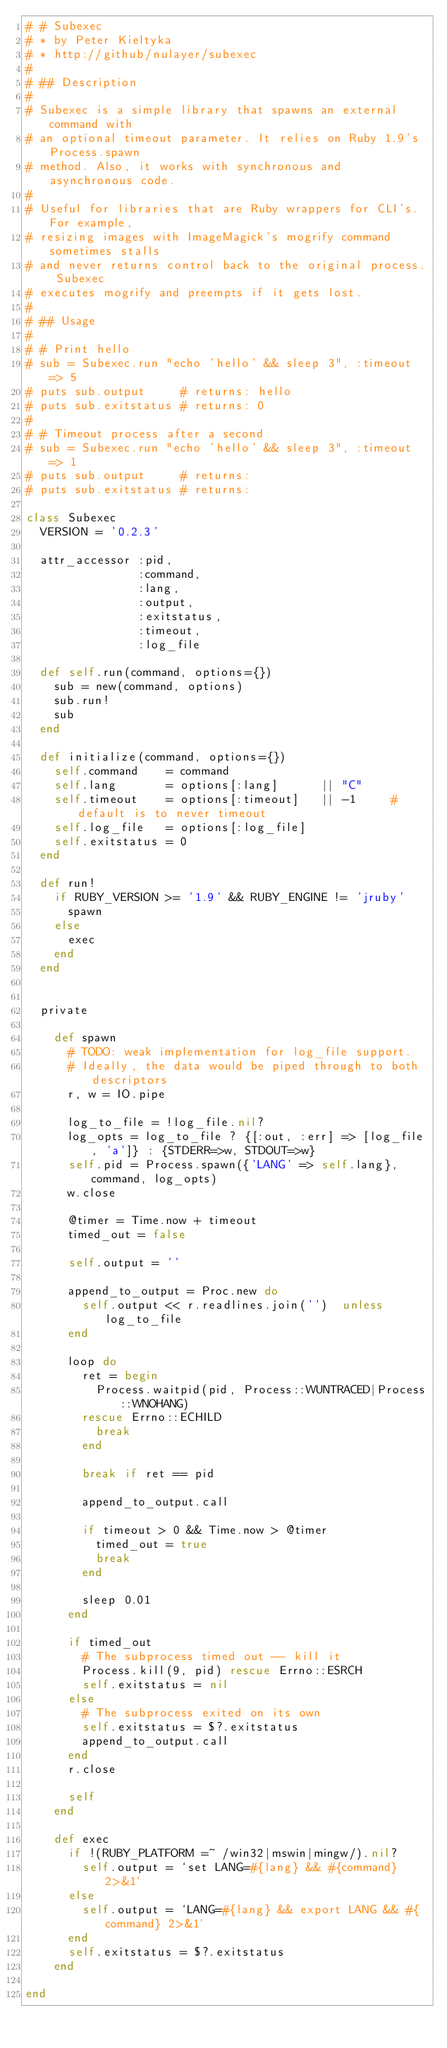Convert code to text. <code><loc_0><loc_0><loc_500><loc_500><_Ruby_># # Subexec
# * by Peter Kieltyka
# * http://github/nulayer/subexec
#
# ## Description
#
# Subexec is a simple library that spawns an external command with
# an optional timeout parameter. It relies on Ruby 1.9's Process.spawn
# method. Also, it works with synchronous and asynchronous code.
#
# Useful for libraries that are Ruby wrappers for CLI's. For example,
# resizing images with ImageMagick's mogrify command sometimes stalls
# and never returns control back to the original process. Subexec
# executes mogrify and preempts if it gets lost.
#
# ## Usage
#
# # Print hello
# sub = Subexec.run "echo 'hello' && sleep 3", :timeout => 5
# puts sub.output     # returns: hello
# puts sub.exitstatus # returns: 0
#
# # Timeout process after a second
# sub = Subexec.run "echo 'hello' && sleep 3", :timeout => 1
# puts sub.output     # returns:
# puts sub.exitstatus # returns:

class Subexec
  VERSION = '0.2.3'

  attr_accessor :pid,
                :command,
                :lang,
                :output,
                :exitstatus,
                :timeout,
                :log_file

  def self.run(command, options={})
    sub = new(command, options)
    sub.run!
    sub
  end

  def initialize(command, options={})
    self.command    = command
    self.lang       = options[:lang]      || "C"
    self.timeout    = options[:timeout]   || -1     # default is to never timeout
    self.log_file   = options[:log_file]
    self.exitstatus = 0
  end

  def run!
    if RUBY_VERSION >= '1.9' && RUBY_ENGINE != 'jruby'
      spawn
    else
      exec
    end
  end


  private

    def spawn
      # TODO: weak implementation for log_file support.
      # Ideally, the data would be piped through to both descriptors
      r, w = IO.pipe

      log_to_file = !log_file.nil?
      log_opts = log_to_file ? {[:out, :err] => [log_file, 'a']} : {STDERR=>w, STDOUT=>w}
      self.pid = Process.spawn({'LANG' => self.lang}, command, log_opts)
      w.close

      @timer = Time.now + timeout
      timed_out = false

      self.output = ''

      append_to_output = Proc.new do
        self.output << r.readlines.join('')  unless log_to_file
      end

      loop do
        ret = begin
          Process.waitpid(pid, Process::WUNTRACED|Process::WNOHANG)
        rescue Errno::ECHILD
          break
        end

        break if ret == pid

        append_to_output.call

        if timeout > 0 && Time.now > @timer
          timed_out = true
          break
        end

        sleep 0.01
      end

      if timed_out
        # The subprocess timed out -- kill it
        Process.kill(9, pid) rescue Errno::ESRCH
        self.exitstatus = nil
      else
        # The subprocess exited on its own
        self.exitstatus = $?.exitstatus
        append_to_output.call
      end
      r.close

      self
    end

    def exec
      if !(RUBY_PLATFORM =~ /win32|mswin|mingw/).nil?
        self.output = `set LANG=#{lang} && #{command} 2>&1`
      else
        self.output = `LANG=#{lang} && export LANG && #{command} 2>&1`
      end
      self.exitstatus = $?.exitstatus
    end

end
</code> 